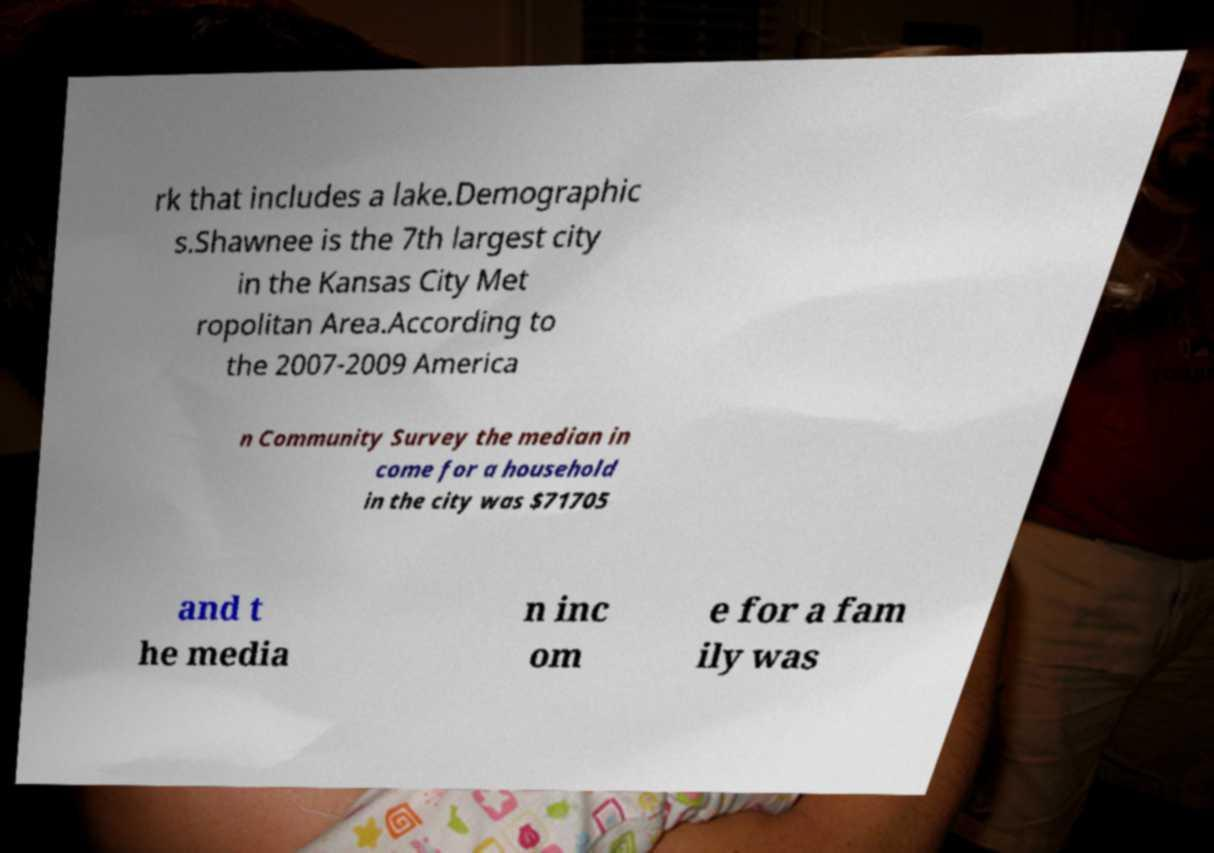There's text embedded in this image that I need extracted. Can you transcribe it verbatim? rk that includes a lake.Demographic s.Shawnee is the 7th largest city in the Kansas City Met ropolitan Area.According to the 2007-2009 America n Community Survey the median in come for a household in the city was $71705 and t he media n inc om e for a fam ily was 